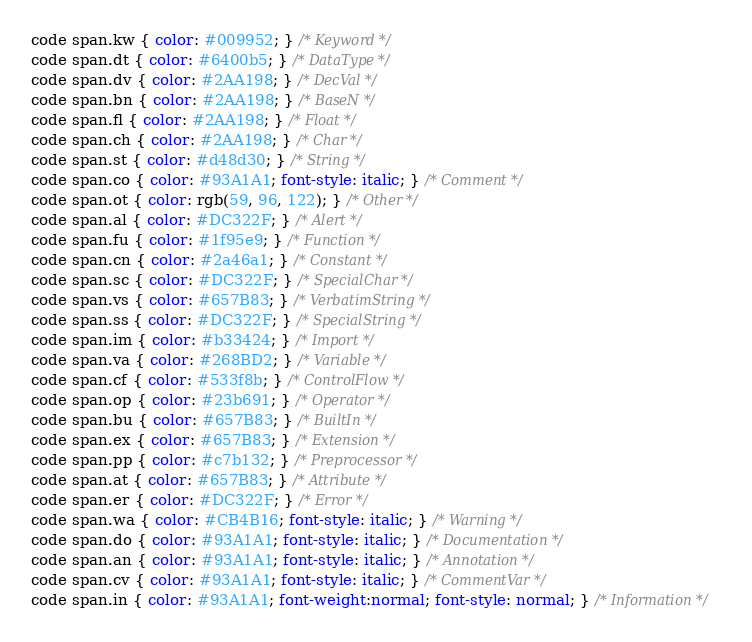<code> <loc_0><loc_0><loc_500><loc_500><_CSS_>code span.kw { color: #009952; } /* Keyword */
code span.dt { color: #6400b5; } /* DataType */
code span.dv { color: #2AA198; } /* DecVal */
code span.bn { color: #2AA198; } /* BaseN */
code span.fl { color: #2AA198; } /* Float */
code span.ch { color: #2AA198; } /* Char */
code span.st { color: #d48d30; } /* String */
code span.co { color: #93A1A1; font-style: italic; } /* Comment */
code span.ot { color: rgb(59, 96, 122); } /* Other */
code span.al { color: #DC322F; } /* Alert */
code span.fu { color: #1f95e9; } /* Function */
code span.cn { color: #2a46a1; } /* Constant */
code span.sc { color: #DC322F; } /* SpecialChar */
code span.vs { color: #657B83; } /* VerbatimString */
code span.ss { color: #DC322F; } /* SpecialString */
code span.im { color: #b33424; } /* Import */
code span.va { color: #268BD2; } /* Variable */
code span.cf { color: #533f8b; } /* ControlFlow */
code span.op { color: #23b691; } /* Operator */
code span.bu { color: #657B83; } /* BuiltIn */
code span.ex { color: #657B83; } /* Extension */
code span.pp { color: #c7b132; } /* Preprocessor */
code span.at { color: #657B83; } /* Attribute */
code span.er { color: #DC322F; } /* Error */
code span.wa { color: #CB4B16; font-style: italic; } /* Warning */
code span.do { color: #93A1A1; font-style: italic; } /* Documentation */
code span.an { color: #93A1A1; font-style: italic; } /* Annotation */
code span.cv { color: #93A1A1; font-style: italic; } /* CommentVar */
code span.in { color: #93A1A1; font-weight:normal; font-style: normal; } /* Information */</code> 